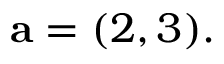Convert formula to latex. <formula><loc_0><loc_0><loc_500><loc_500>a = ( 2 , 3 ) .</formula> 